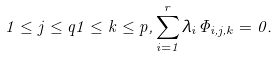<formula> <loc_0><loc_0><loc_500><loc_500>1 \leq j \leq q 1 \leq k \leq p , \sum _ { i = 1 } ^ { r } \lambda _ { i } \Phi _ { i , j , k } = 0 .</formula> 